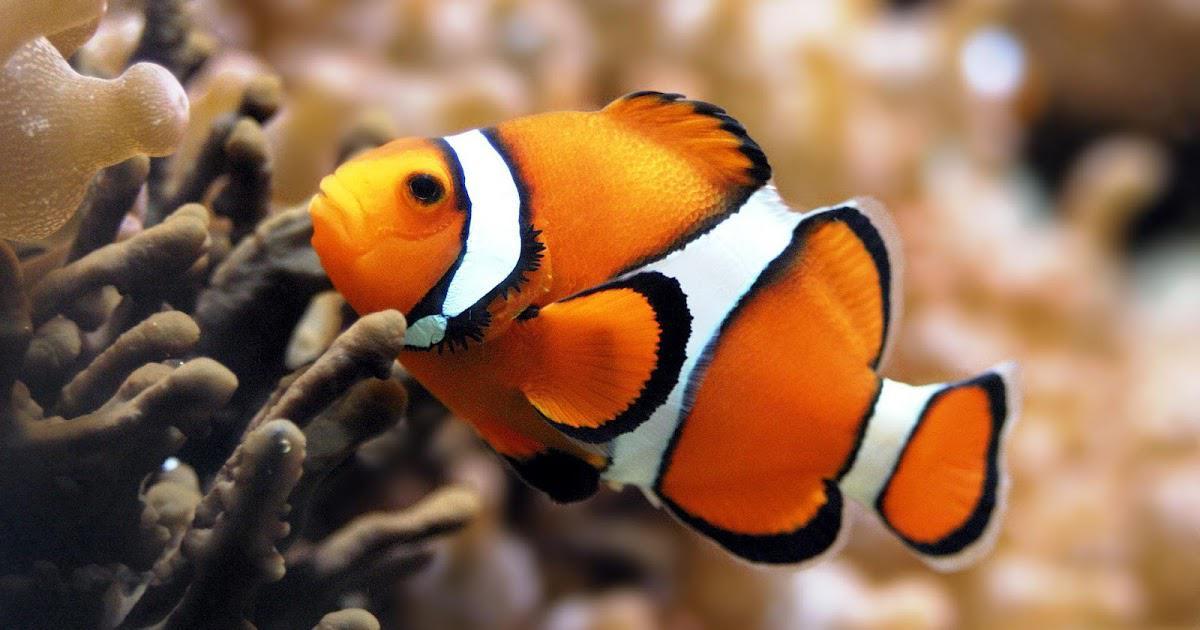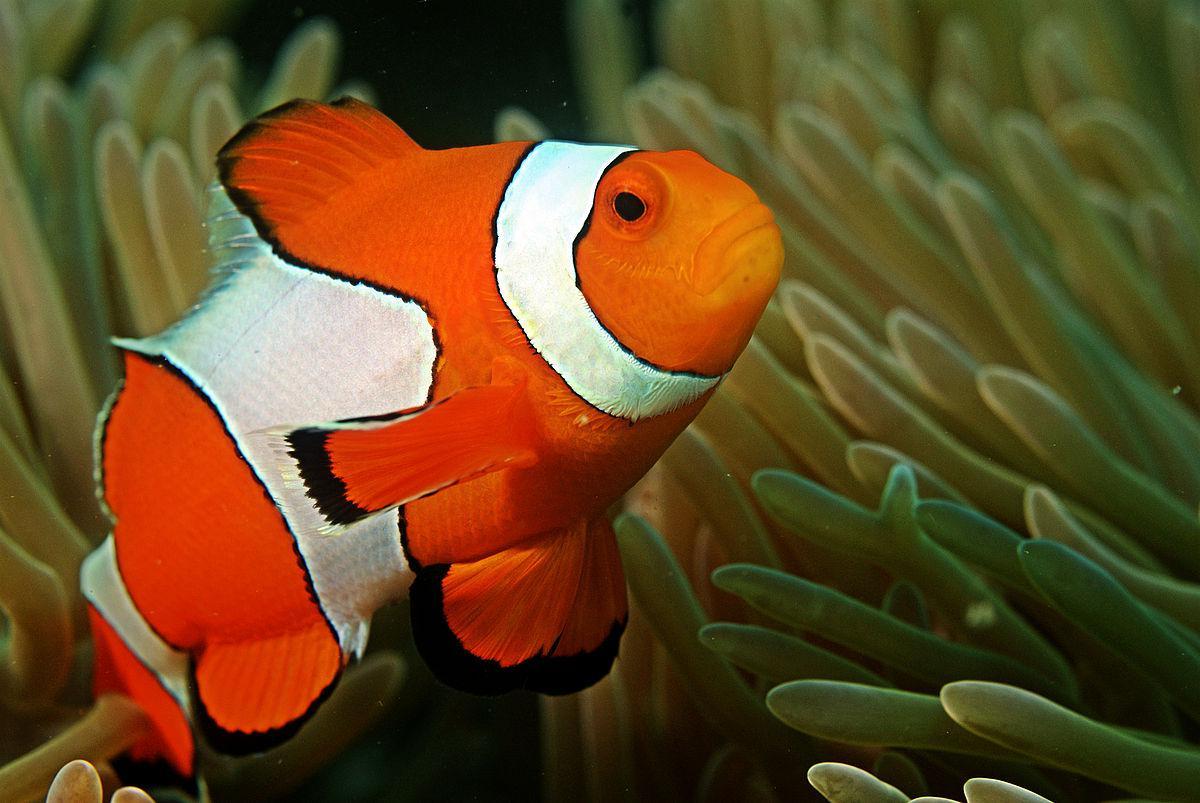The first image is the image on the left, the second image is the image on the right. Examine the images to the left and right. Is the description "There are 4 clownfish." accurate? Answer yes or no. No. 